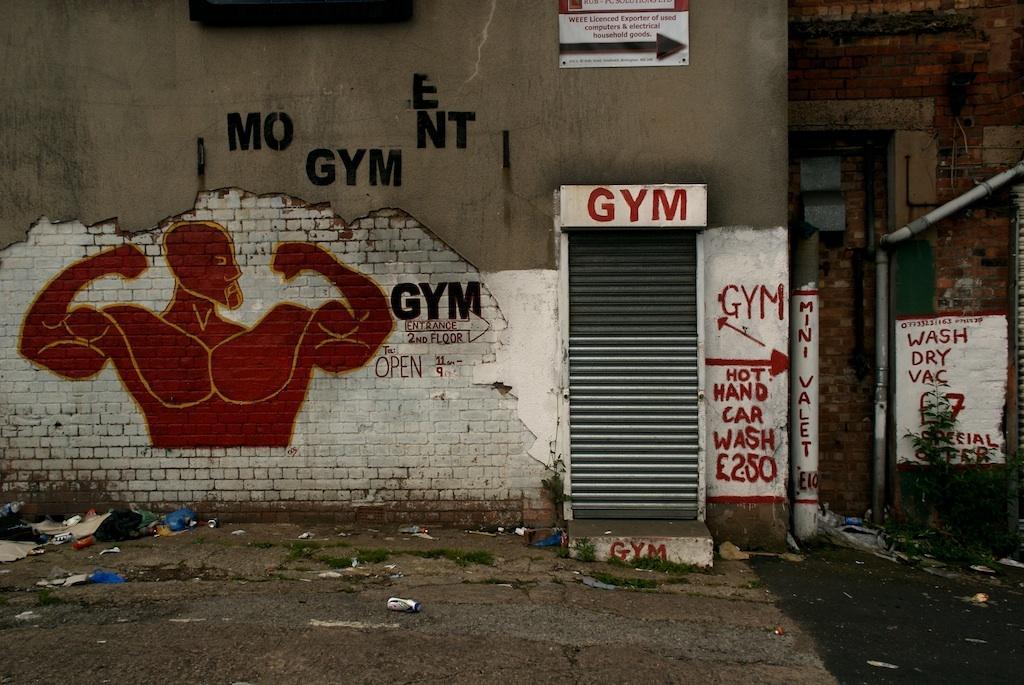Describe this image in one or two sentences. In this image I see the buildings and I see the walls on which there is something written and I see the depiction of a person over here and I see a pole over here and I see the path on which there are few things. 